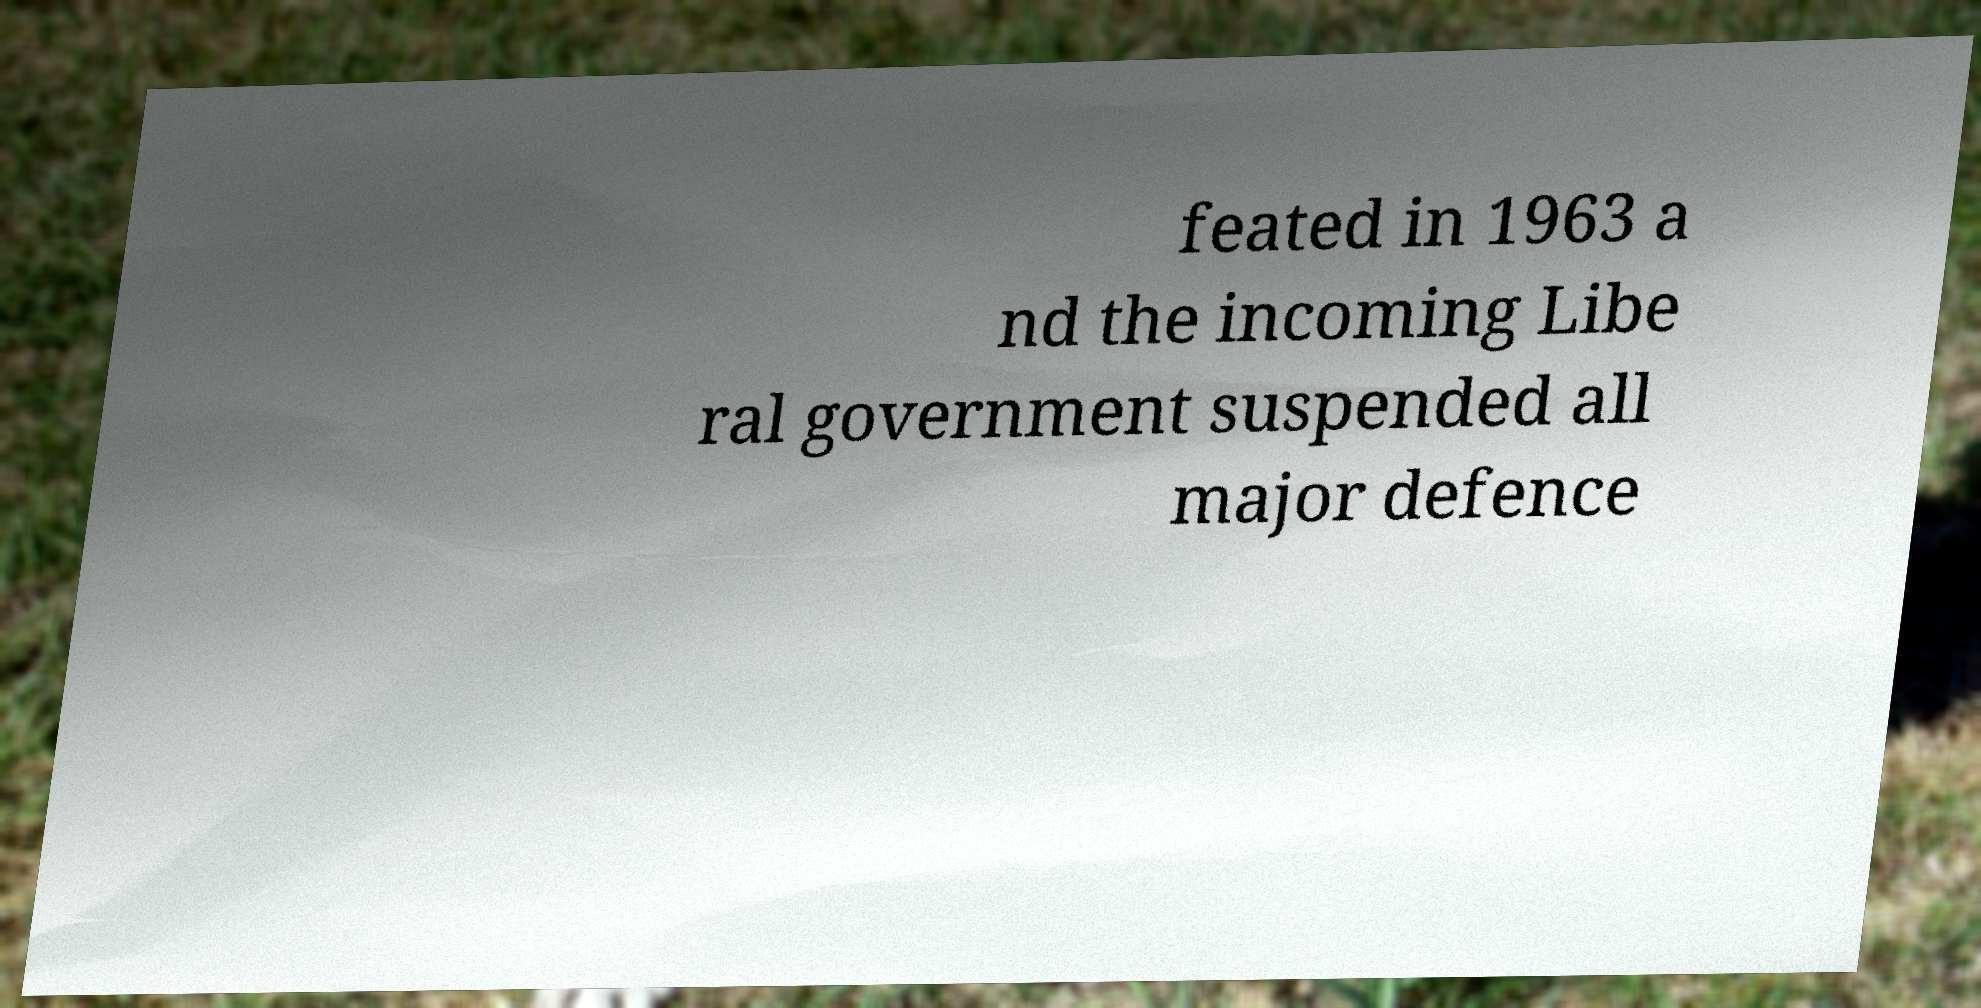There's text embedded in this image that I need extracted. Can you transcribe it verbatim? feated in 1963 a nd the incoming Libe ral government suspended all major defence 